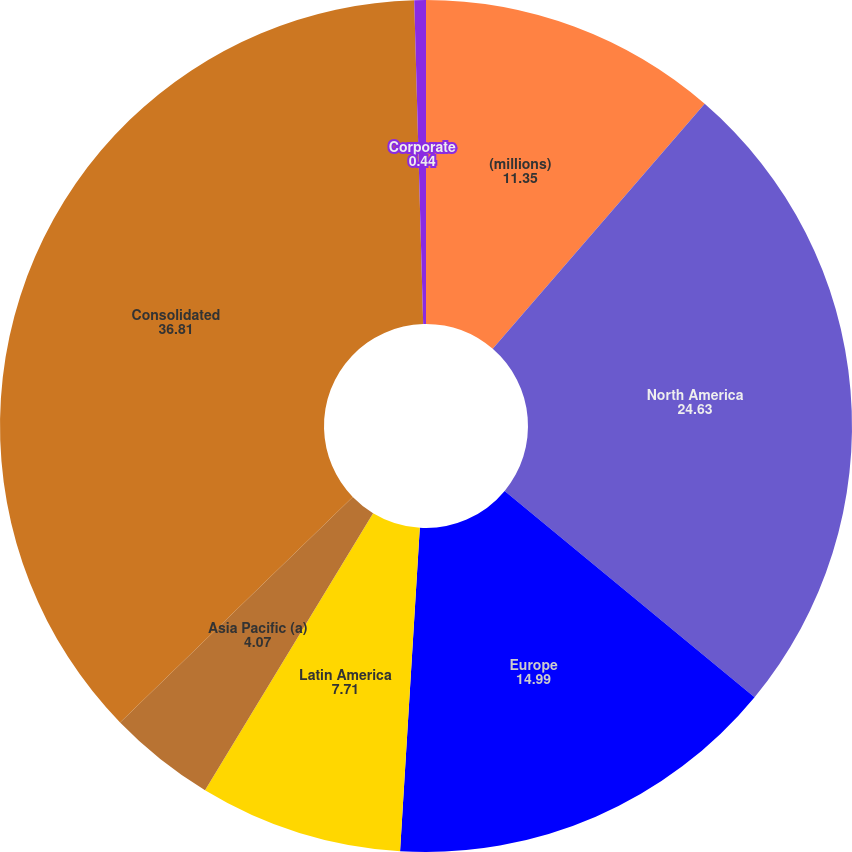Convert chart to OTSL. <chart><loc_0><loc_0><loc_500><loc_500><pie_chart><fcel>(millions)<fcel>North America<fcel>Europe<fcel>Latin America<fcel>Asia Pacific (a)<fcel>Consolidated<fcel>Corporate<nl><fcel>11.35%<fcel>24.63%<fcel>14.99%<fcel>7.71%<fcel>4.07%<fcel>36.81%<fcel>0.44%<nl></chart> 